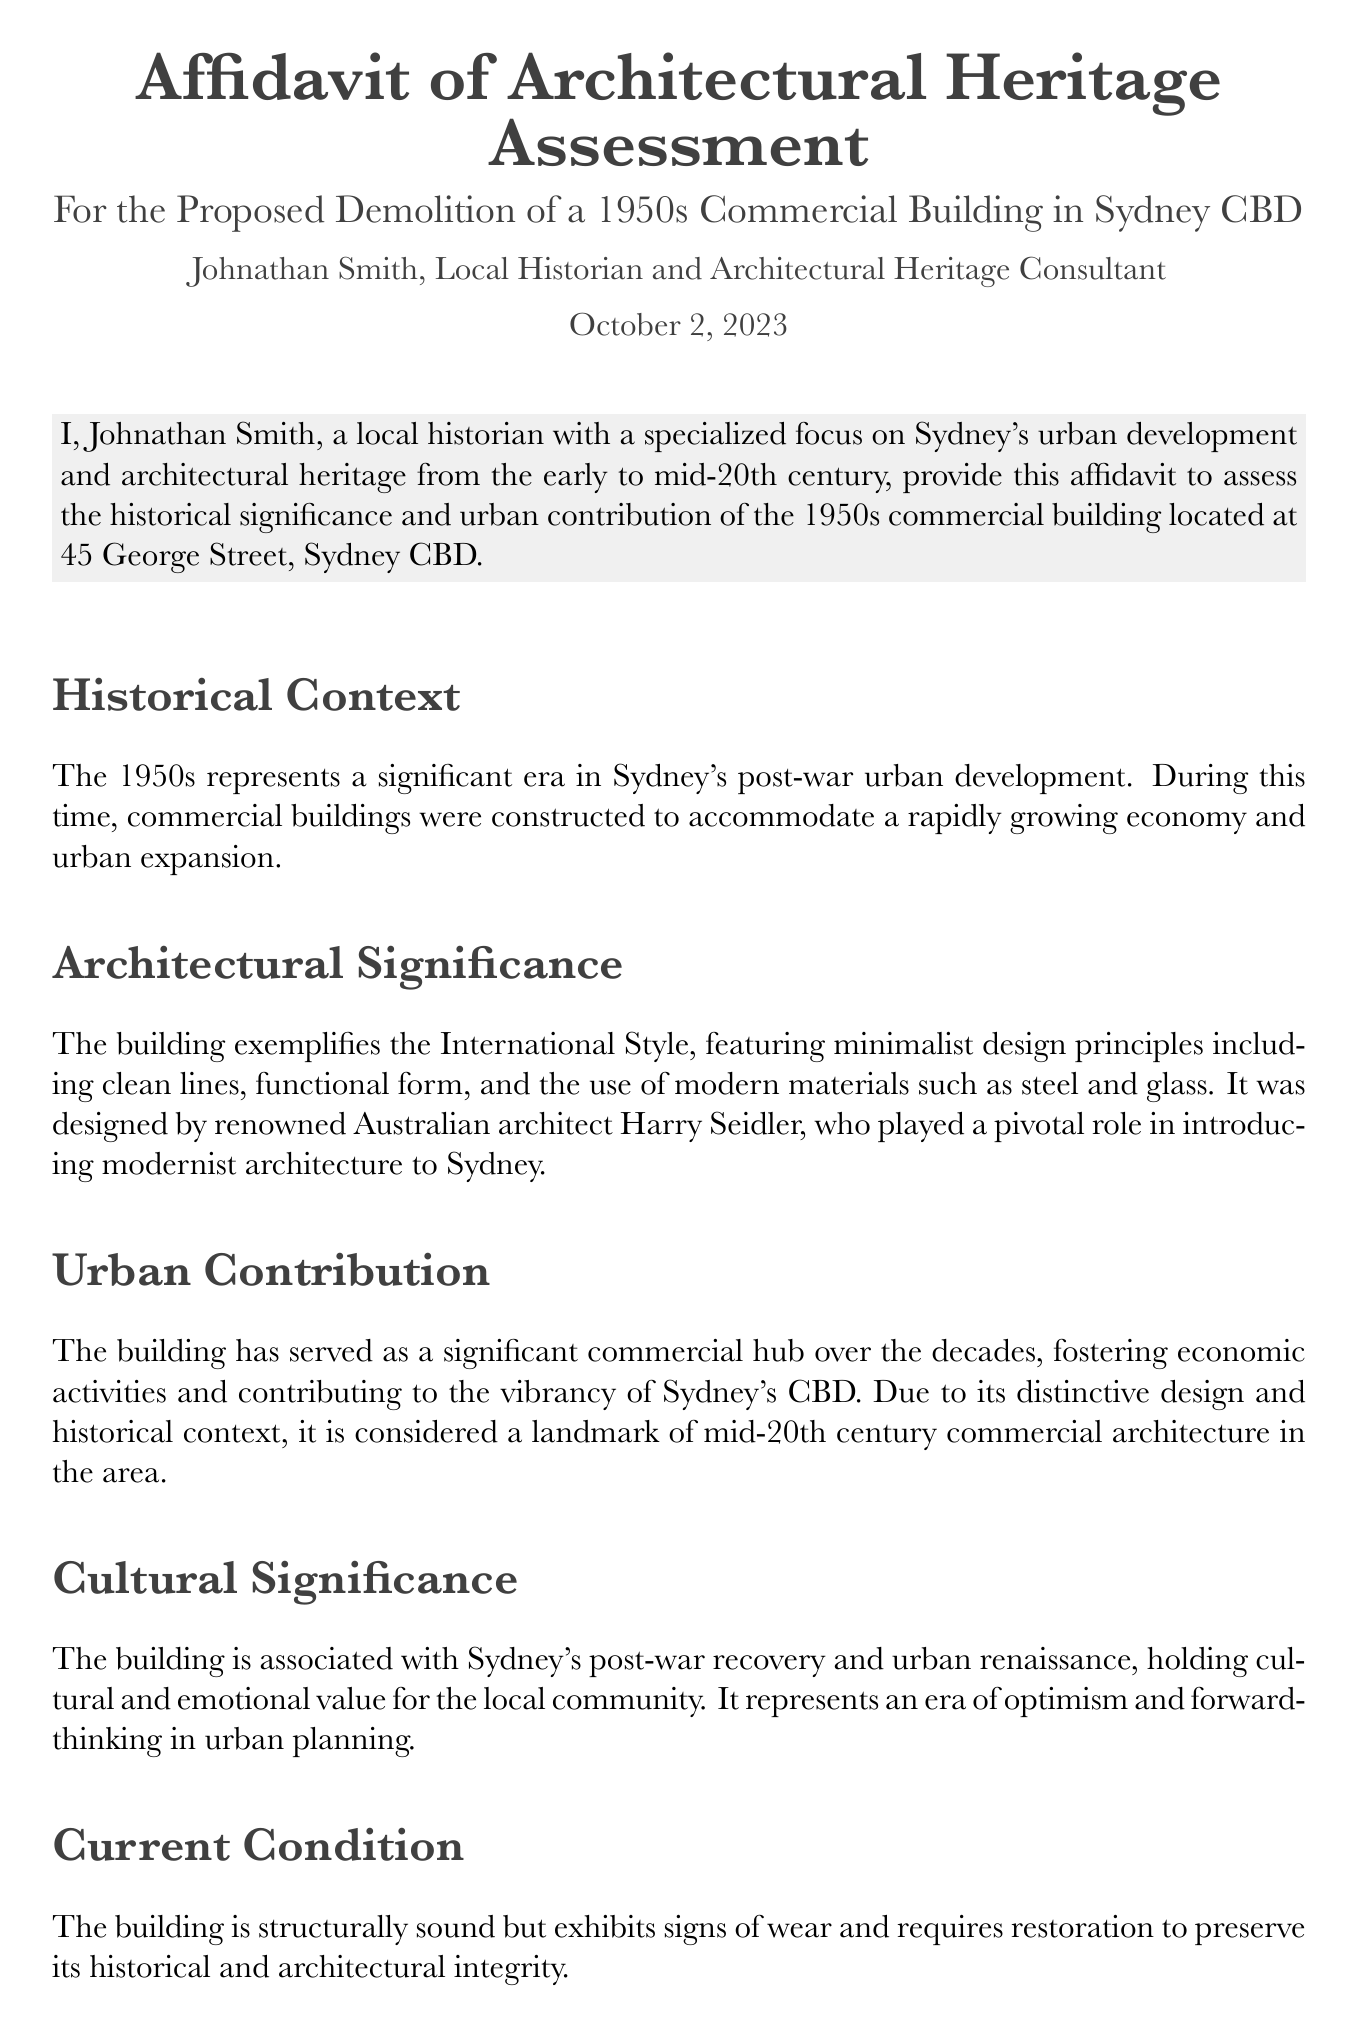What is the date of the affidavit? The date of the affidavit is located at the top of the document, which states "October 2, 2023."
Answer: October 2, 2023 Who is the author of the affidavit? The author's name is mentioned in the document and is indicated as "Johnathan Smith."
Answer: Johnathan Smith What style of architecture does the building exemplify? The document specifies that the building exemplifies the "International Style."
Answer: International Style What is the address of the building assessed in the affidavit? The address of the building is provided in the document as "45 George Street, Sydney CBD."
Answer: 45 George Street, Sydney CBD What role did Harry Seidler play in relation to the building? The document states Harry Seidler is the "renowned Australian architect" who designed the building.
Answer: Renowned Australian architect 